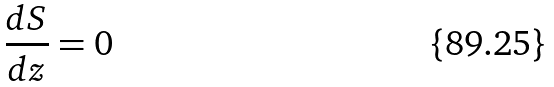Convert formula to latex. <formula><loc_0><loc_0><loc_500><loc_500>\frac { d S } { d z } = 0</formula> 